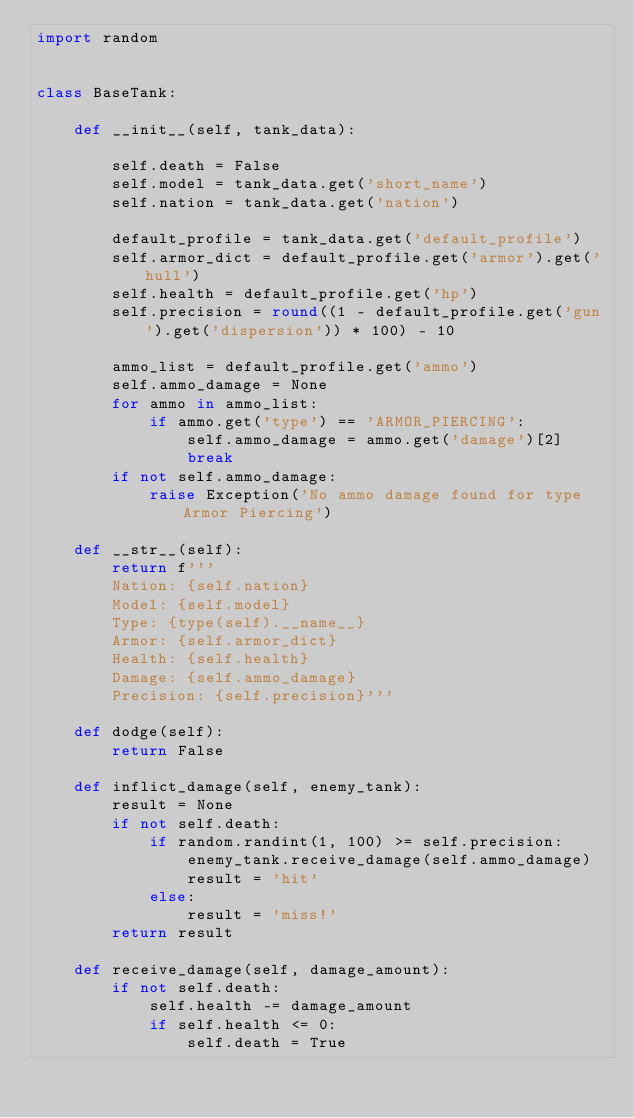Convert code to text. <code><loc_0><loc_0><loc_500><loc_500><_Python_>import random


class BaseTank:

    def __init__(self, tank_data):

        self.death = False
        self.model = tank_data.get('short_name')
        self.nation = tank_data.get('nation')

        default_profile = tank_data.get('default_profile')
        self.armor_dict = default_profile.get('armor').get('hull')
        self.health = default_profile.get('hp')
        self.precision = round((1 - default_profile.get('gun').get('dispersion')) * 100) - 10

        ammo_list = default_profile.get('ammo')
        self.ammo_damage = None
        for ammo in ammo_list:
            if ammo.get('type') == 'ARMOR_PIERCING':
                self.ammo_damage = ammo.get('damage')[2]
                break
        if not self.ammo_damage:
            raise Exception('No ammo damage found for type Armor Piercing')

    def __str__(self):
        return f'''
        Nation: {self.nation}
        Model: {self.model}
        Type: {type(self).__name__}
        Armor: {self.armor_dict} 
        Health: {self.health} 
        Damage: {self.ammo_damage}
        Precision: {self.precision}'''

    def dodge(self):
        return False

    def inflict_damage(self, enemy_tank):
        result = None
        if not self.death:
            if random.randint(1, 100) >= self.precision:
                enemy_tank.receive_damage(self.ammo_damage)
                result = 'hit'
            else:
                result = 'miss!'
        return result

    def receive_damage(self, damage_amount):
        if not self.death:
            self.health -= damage_amount
            if self.health <= 0:
                self.death = True
</code> 